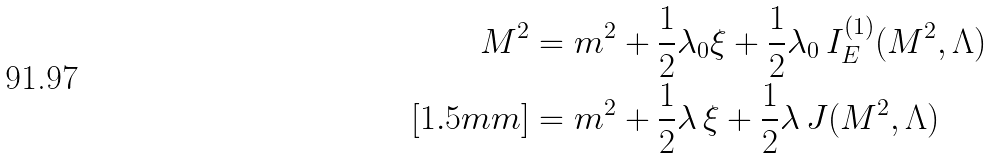Convert formula to latex. <formula><loc_0><loc_0><loc_500><loc_500>M ^ { 2 } & = m ^ { 2 } + \frac { 1 } { 2 } \lambda _ { 0 } \xi + \frac { 1 } { 2 } \lambda _ { 0 } \, I _ { E } ^ { ( 1 ) } ( M ^ { 2 } , \Lambda ) \\ [ 1 . 5 m m ] & = m ^ { 2 } + \frac { 1 } { 2 } \lambda \, \xi + \frac { 1 } { 2 } \lambda \, J ( M ^ { 2 } , \Lambda )</formula> 